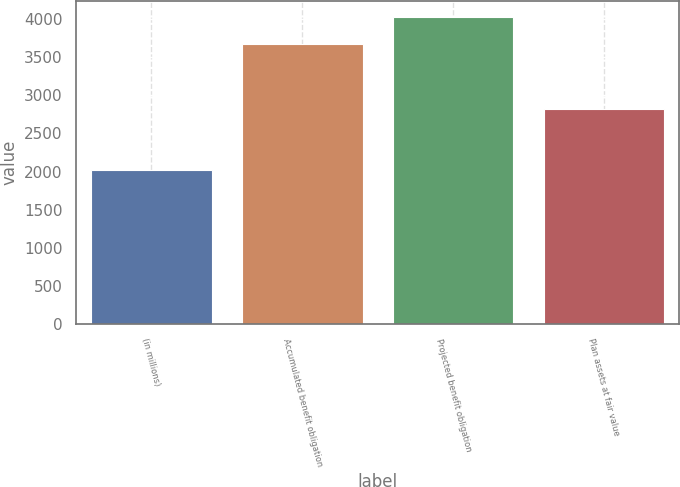Convert chart. <chart><loc_0><loc_0><loc_500><loc_500><bar_chart><fcel>(in millions)<fcel>Accumulated benefit obligation<fcel>Projected benefit obligation<fcel>Plan assets at fair value<nl><fcel>2015<fcel>3678<fcel>4032<fcel>2823<nl></chart> 